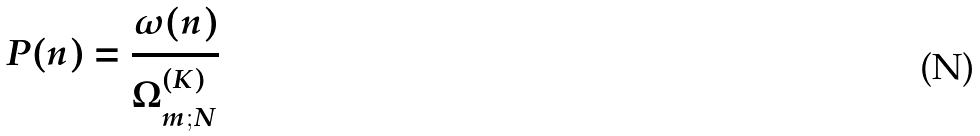Convert formula to latex. <formula><loc_0><loc_0><loc_500><loc_500>P ( n ) = \frac { \mathcal { \omega } ( n ) } { \Omega ^ { ( K ) } _ { m ; N } }</formula> 